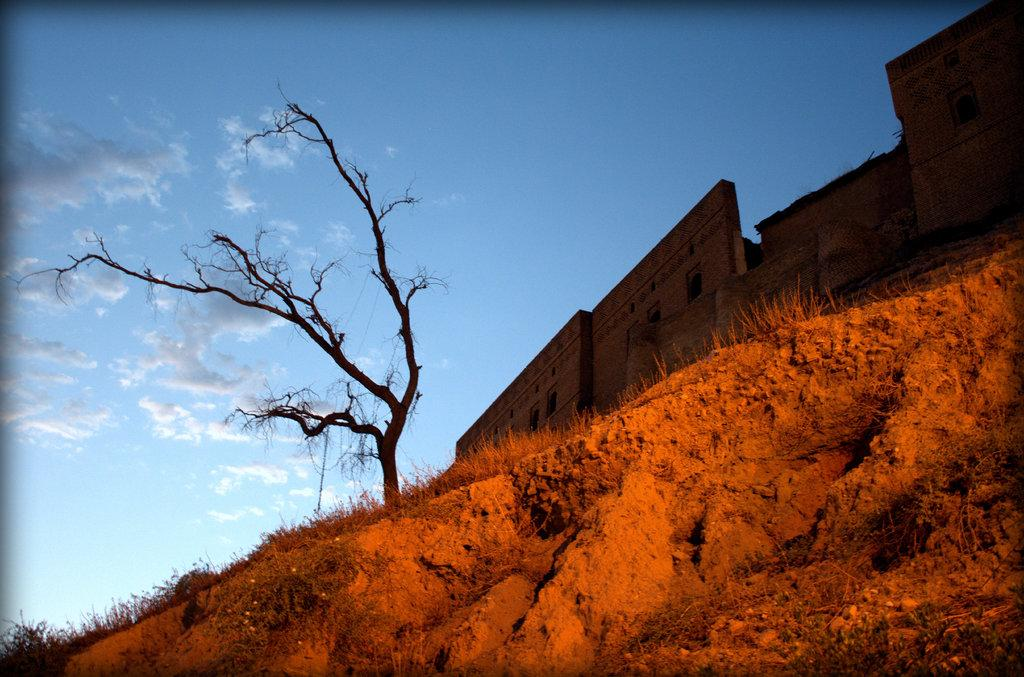What types of natural elements are present in the foreground of the image? There is rock and grass in the foreground of the image. What can be seen in the middle of the image? There is a tree and a wall in the middle of the image. What is visible at the top of the image? The sky is visible at the top of the image. Can you describe the sky in the image? There is a cloud in the sky. How many chairs are stacked on the shelf in the image? There is no shelf or chairs present in the image. 